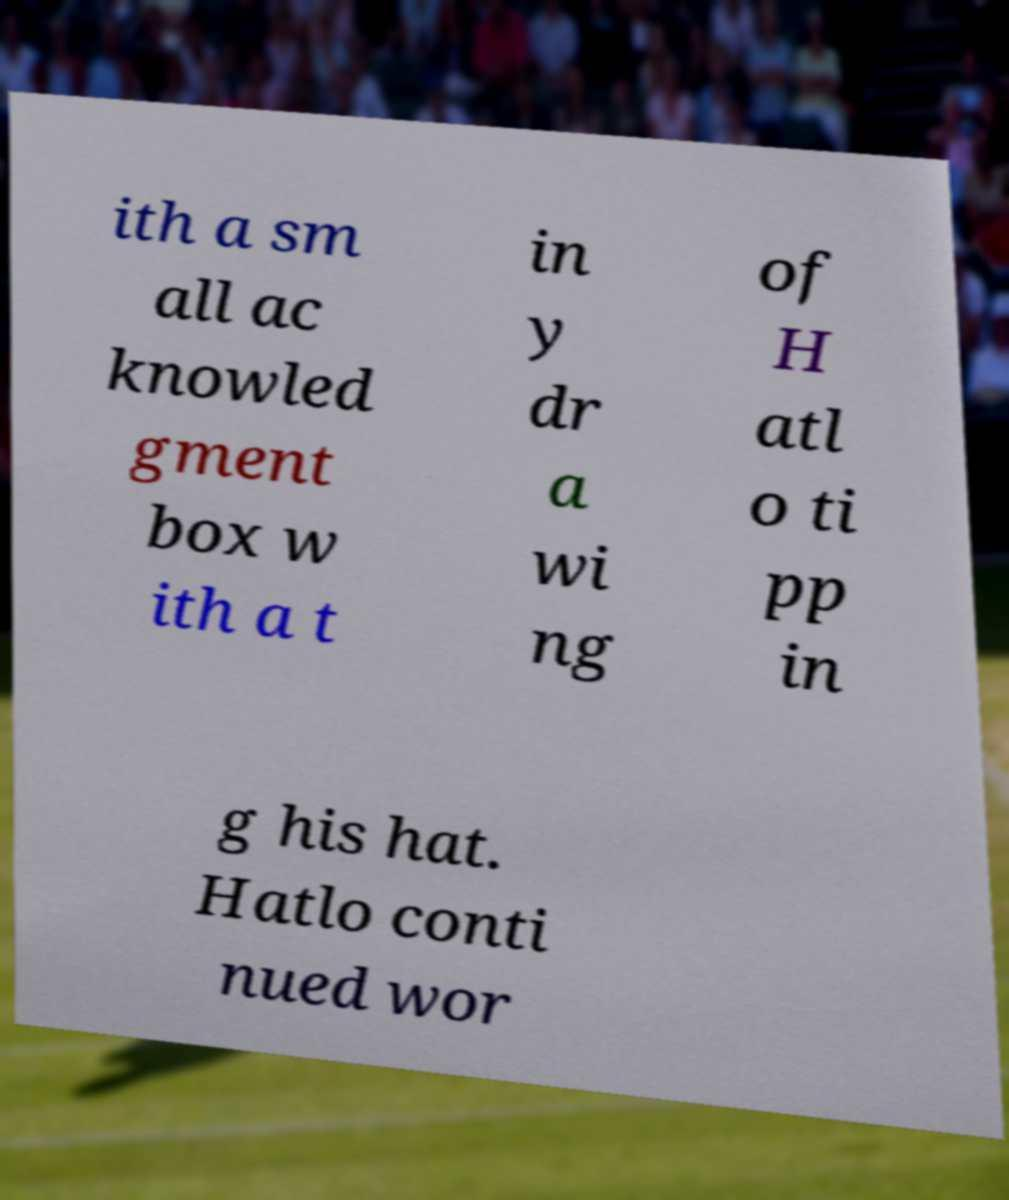There's text embedded in this image that I need extracted. Can you transcribe it verbatim? ith a sm all ac knowled gment box w ith a t in y dr a wi ng of H atl o ti pp in g his hat. Hatlo conti nued wor 